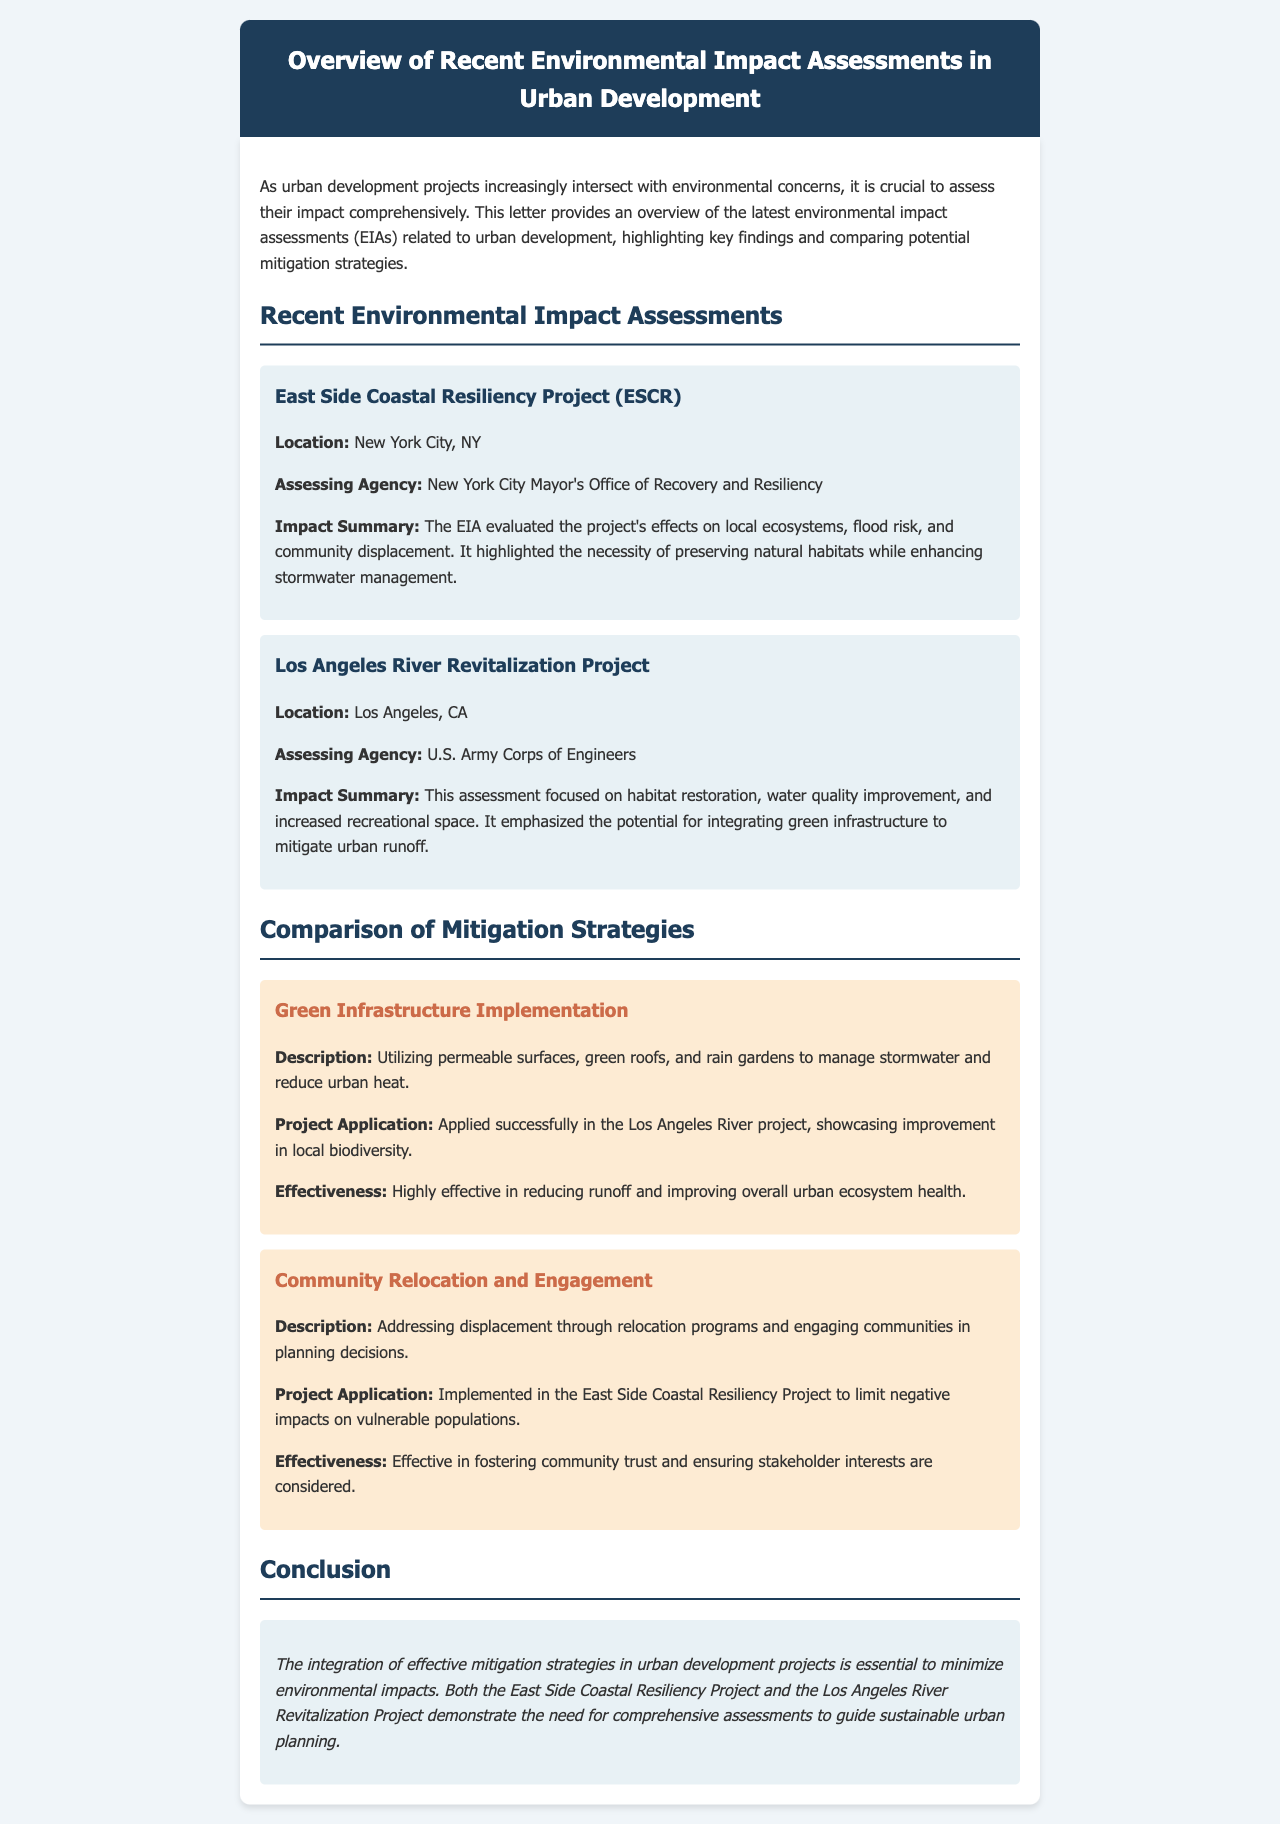What is the location of the East Side Coastal Resiliency Project? The document states that the East Side Coastal Resiliency Project is located in New York City, NY.
Answer: New York City, NY Which agency assessed the Los Angeles River Revitalization Project? The assessing agency for the Los Angeles River Revitalization Project is mentioned as the U.S. Army Corps of Engineers.
Answer: U.S. Army Corps of Engineers What key focus did the EIA for the Los Angeles River emphasize? The document highlights that the EIA for the Los Angeles River focused on habitat restoration, water quality improvement, and increased recreational space.
Answer: Habitat restoration, water quality improvement, and increased recreational space What strategy was applied in the East Side Coastal Resiliency Project to address community displacement? The document states that the strategy implemented in the East Side Coastal Resiliency Project was Community Relocation and Engagement.
Answer: Community Relocation and Engagement How effective is Green Infrastructure Implementation according to the document? The document describes Green Infrastructure Implementation as highly effective in reducing runoff and improving overall urban ecosystem health.
Answer: Highly effective What is the primary concern addressed in both environmental impact assessments? The document indicates that the primary concern in both assessments is the environmental impacts of urban development projects.
Answer: Environmental impacts of urban development projects What is the purpose of this letter? The document outlines that the purpose of this letter is to provide an overview of the latest environmental impact assessments related to urban development.
Answer: Overview of the latest environmental impact assessments Which project application showcases improvement in local biodiversity? The document mentions that the project application showcasing improvement in local biodiversity is the Los Angeles River project.
Answer: Los Angeles River project 